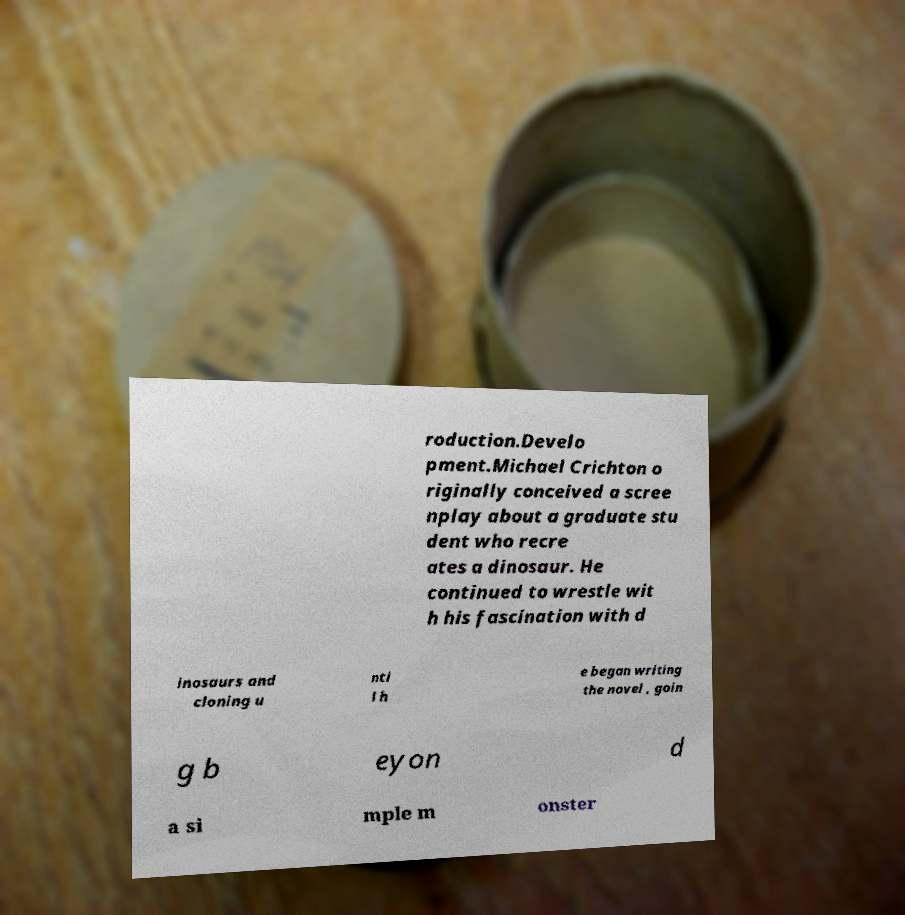For documentation purposes, I need the text within this image transcribed. Could you provide that? roduction.Develo pment.Michael Crichton o riginally conceived a scree nplay about a graduate stu dent who recre ates a dinosaur. He continued to wrestle wit h his fascination with d inosaurs and cloning u nti l h e began writing the novel , goin g b eyon d a si mple m onster 